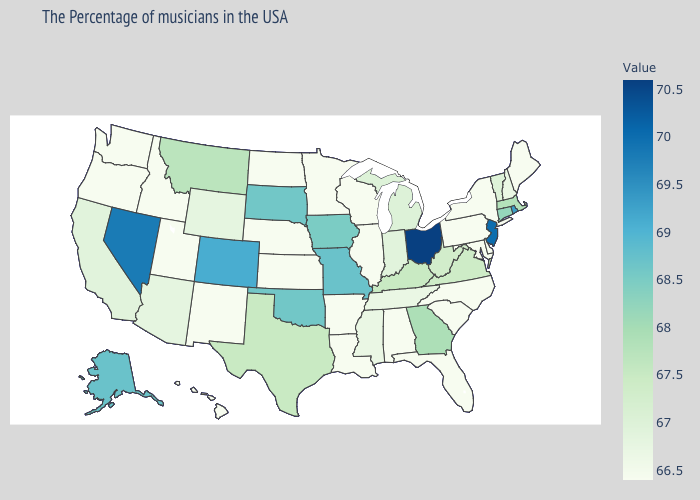Among the states that border Louisiana , which have the highest value?
Short answer required. Texas. Among the states that border Georgia , does Tennessee have the lowest value?
Answer briefly. No. Does Alaska have a higher value than Nevada?
Concise answer only. No. Does Maine have a higher value than Indiana?
Write a very short answer. No. Which states hav the highest value in the MidWest?
Keep it brief. Ohio. 